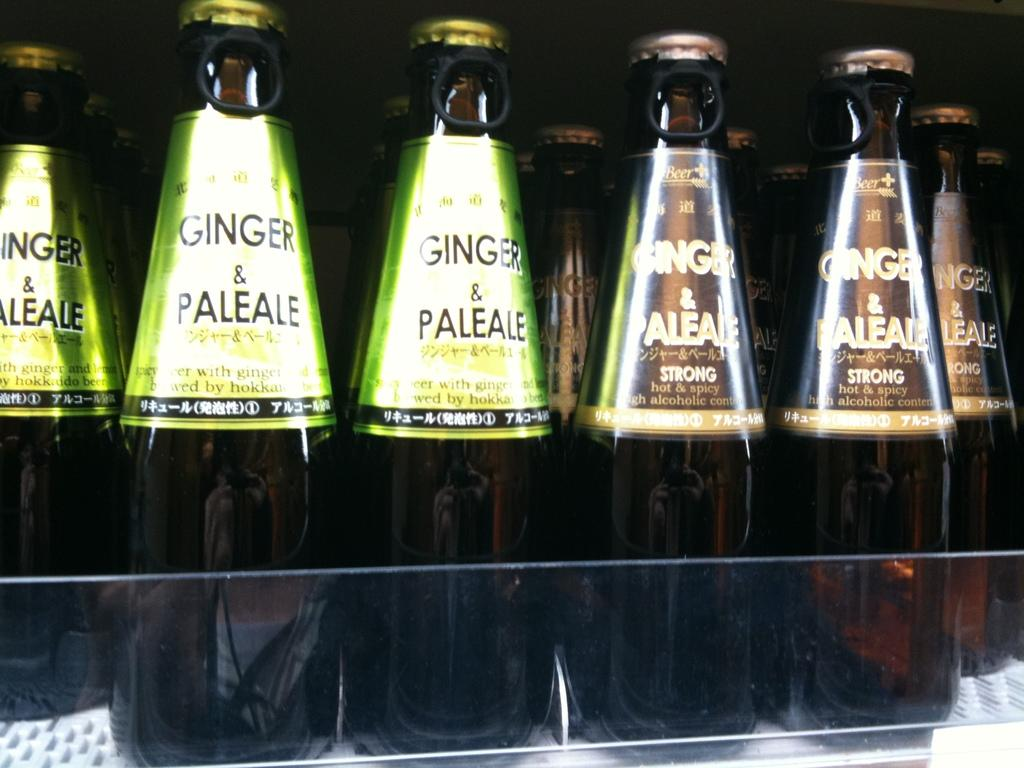<image>
Render a clear and concise summary of the photo. Bottles sitting on a shelf of Ginger and Paleale 